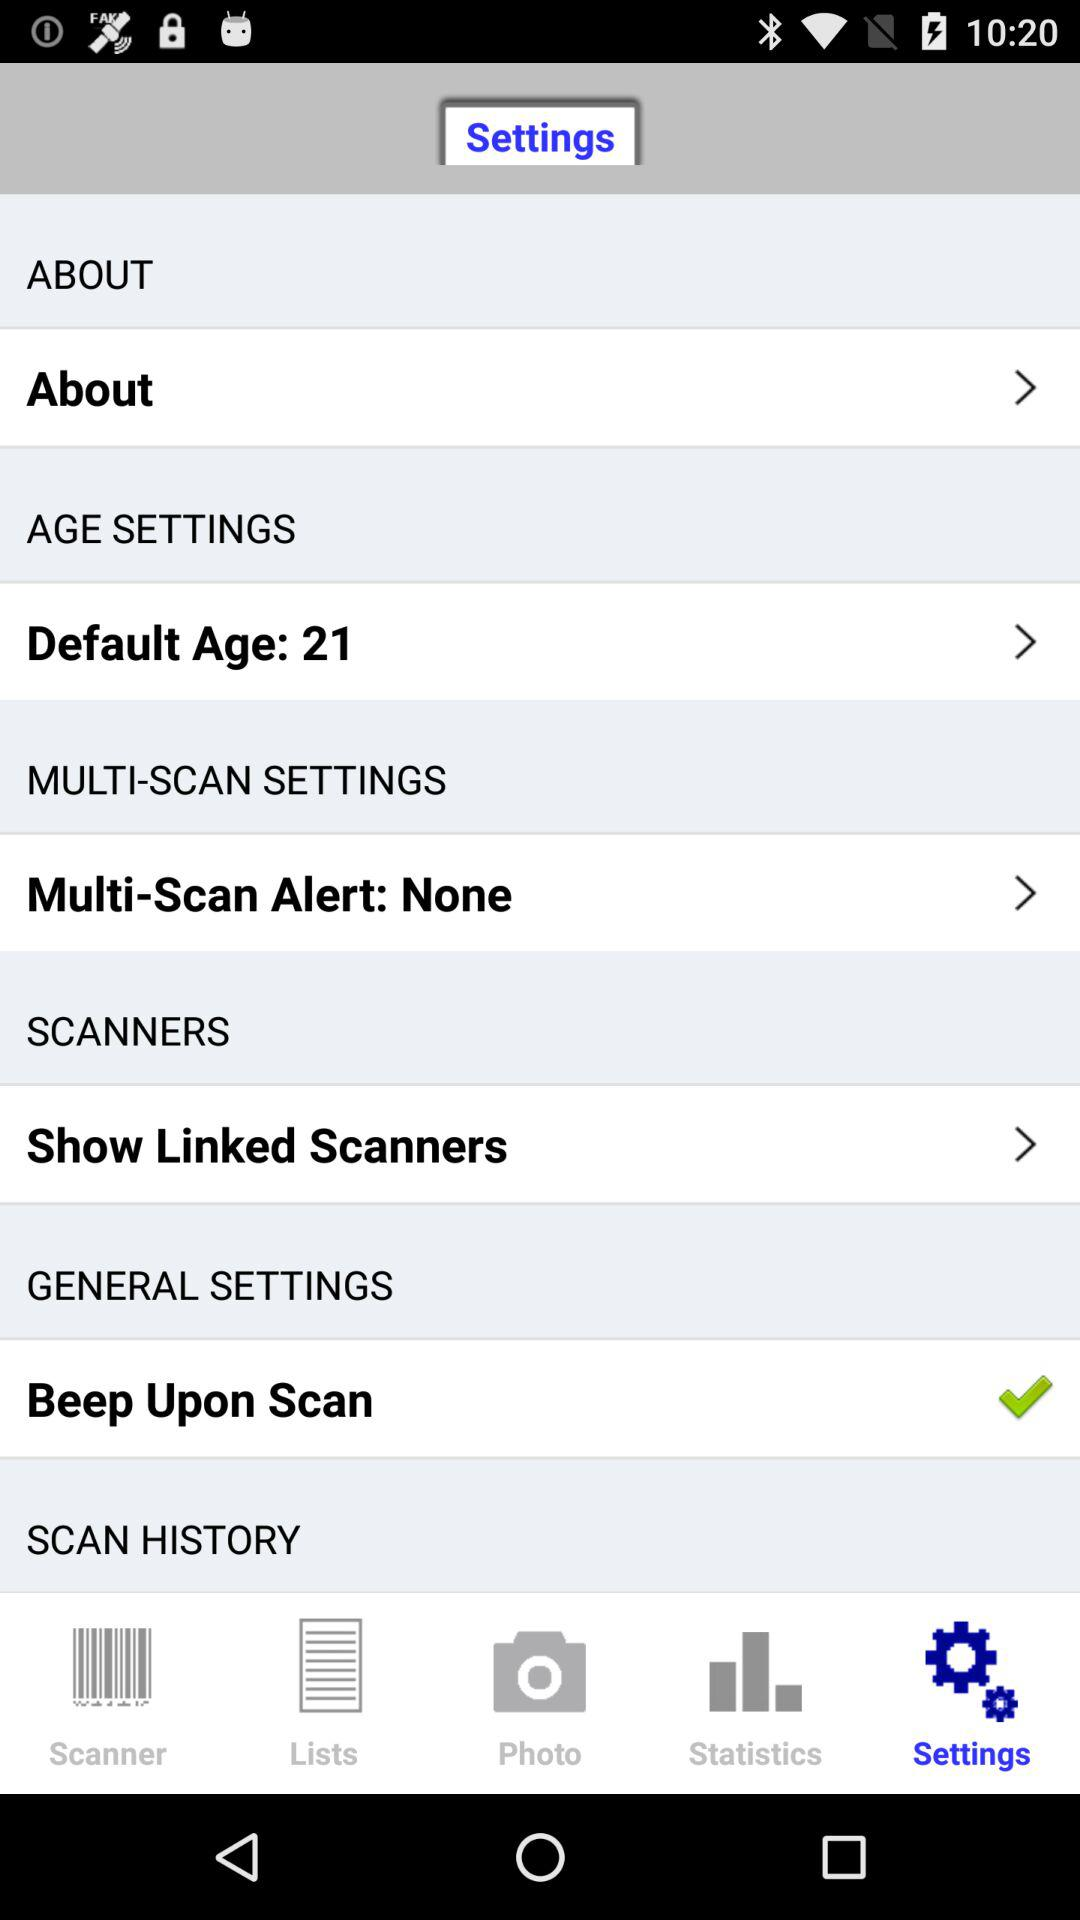What is the default age? The default age is 21. 